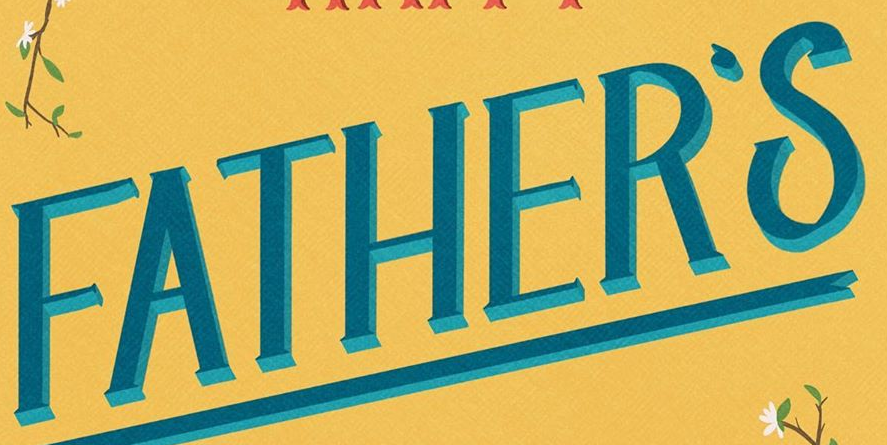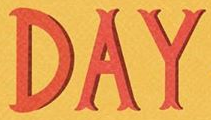Read the text from these images in sequence, separated by a semicolon. FATHER'S; DAY 